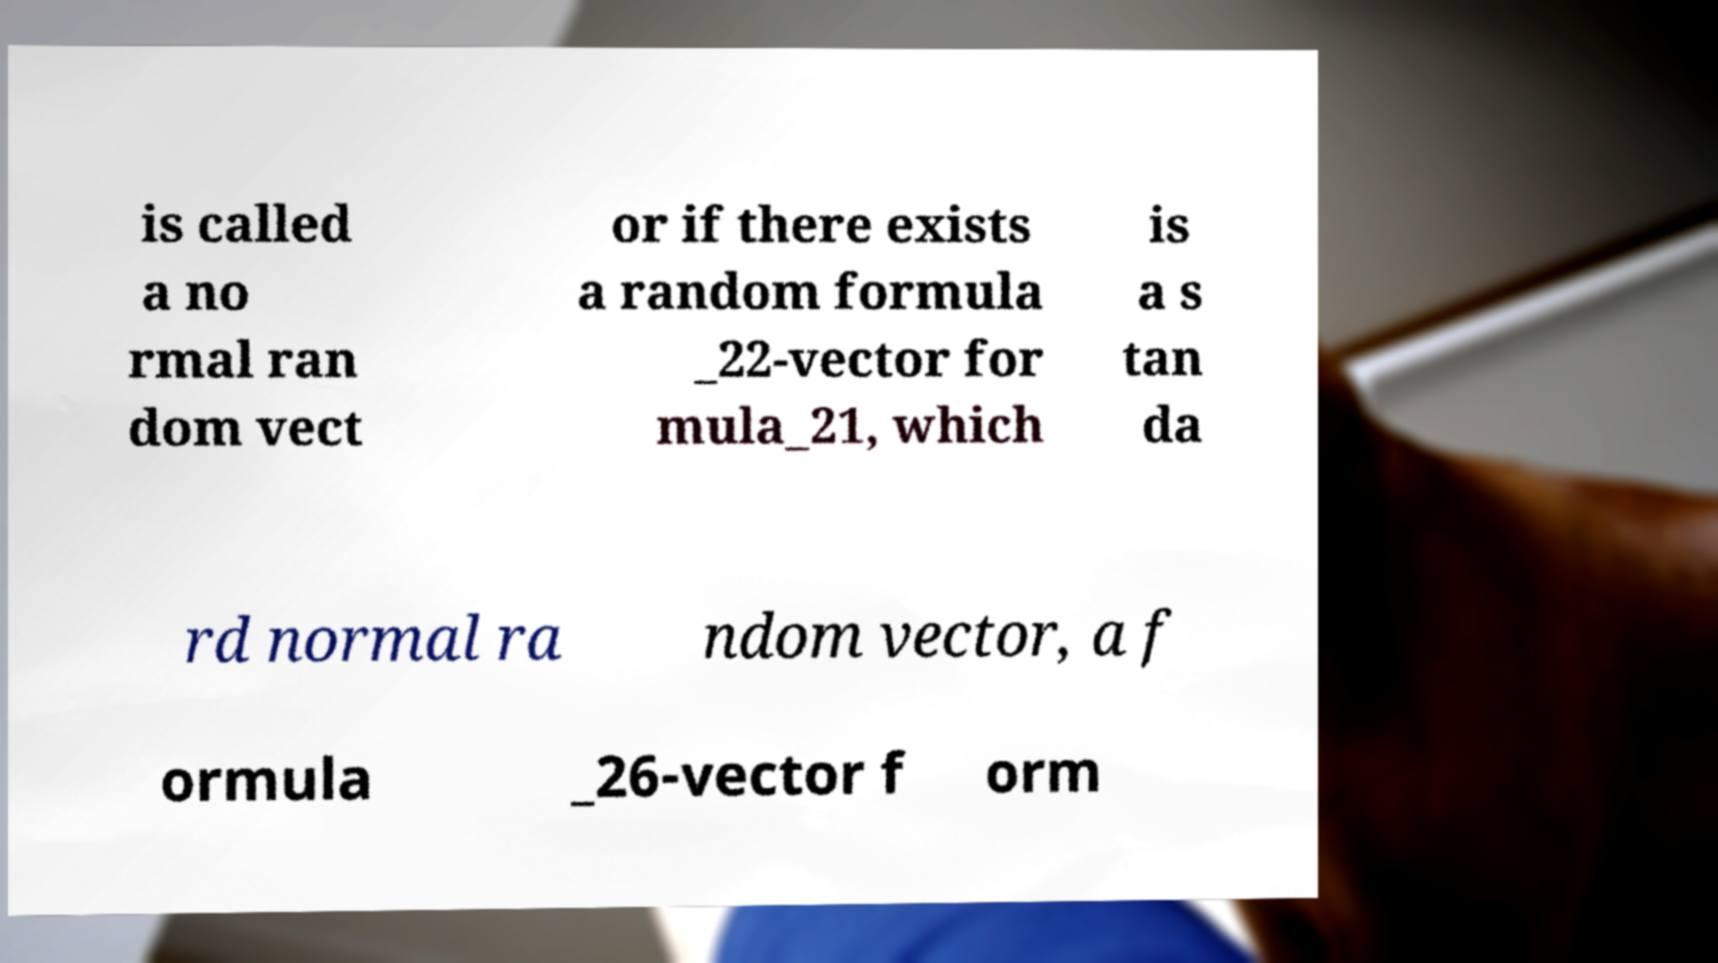Please identify and transcribe the text found in this image. is called a no rmal ran dom vect or if there exists a random formula _22-vector for mula_21, which is a s tan da rd normal ra ndom vector, a f ormula _26-vector f orm 